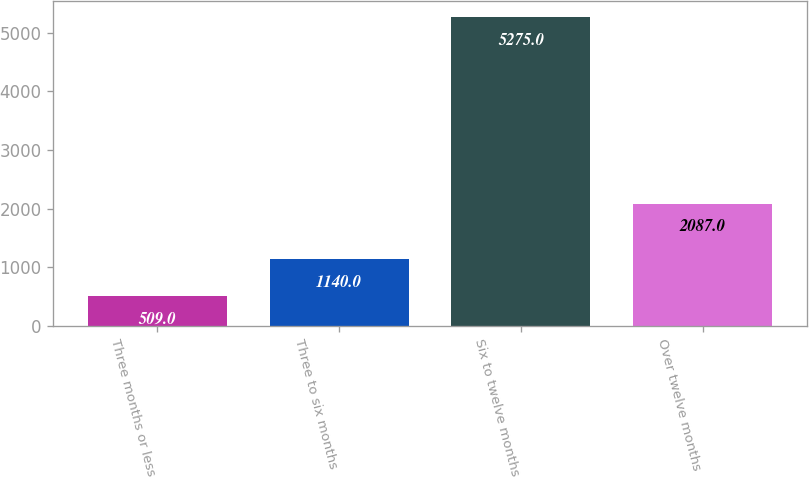Convert chart. <chart><loc_0><loc_0><loc_500><loc_500><bar_chart><fcel>Three months or less<fcel>Three to six months<fcel>Six to twelve months<fcel>Over twelve months<nl><fcel>509<fcel>1140<fcel>5275<fcel>2087<nl></chart> 